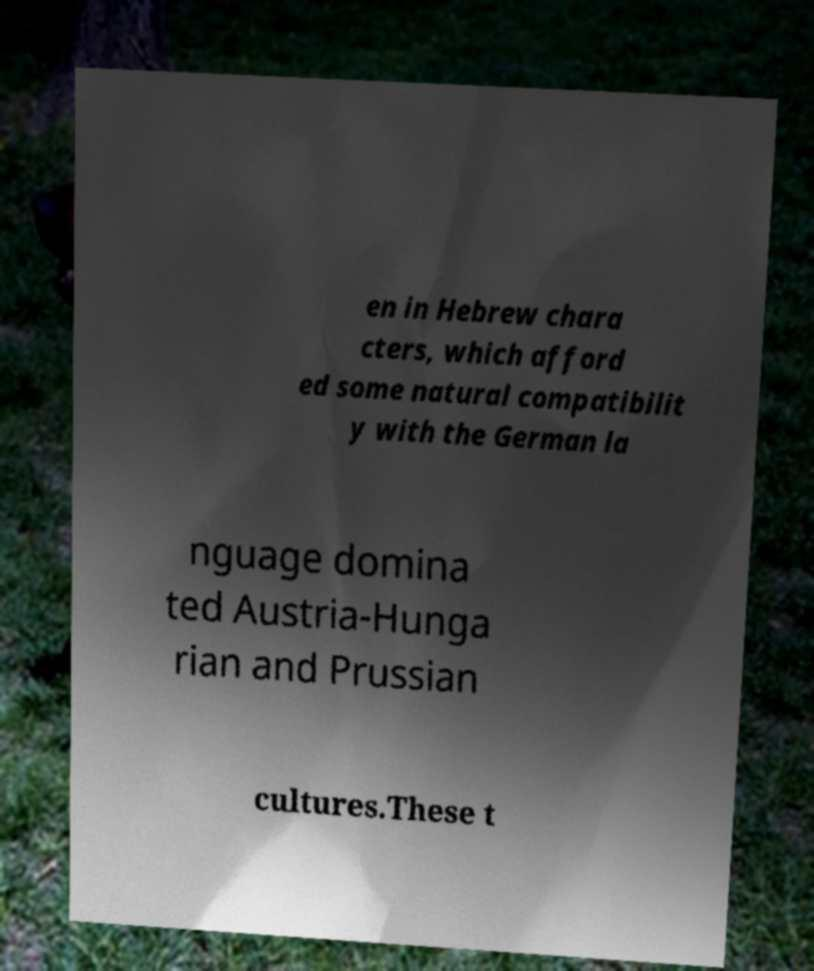What messages or text are displayed in this image? I need them in a readable, typed format. en in Hebrew chara cters, which afford ed some natural compatibilit y with the German la nguage domina ted Austria-Hunga rian and Prussian cultures.These t 